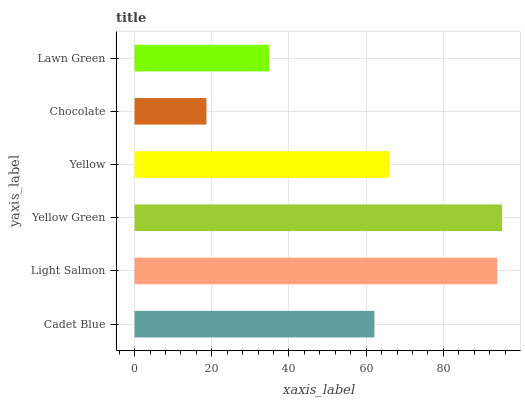Is Chocolate the minimum?
Answer yes or no. Yes. Is Yellow Green the maximum?
Answer yes or no. Yes. Is Light Salmon the minimum?
Answer yes or no. No. Is Light Salmon the maximum?
Answer yes or no. No. Is Light Salmon greater than Cadet Blue?
Answer yes or no. Yes. Is Cadet Blue less than Light Salmon?
Answer yes or no. Yes. Is Cadet Blue greater than Light Salmon?
Answer yes or no. No. Is Light Salmon less than Cadet Blue?
Answer yes or no. No. Is Yellow the high median?
Answer yes or no. Yes. Is Cadet Blue the low median?
Answer yes or no. Yes. Is Chocolate the high median?
Answer yes or no. No. Is Light Salmon the low median?
Answer yes or no. No. 